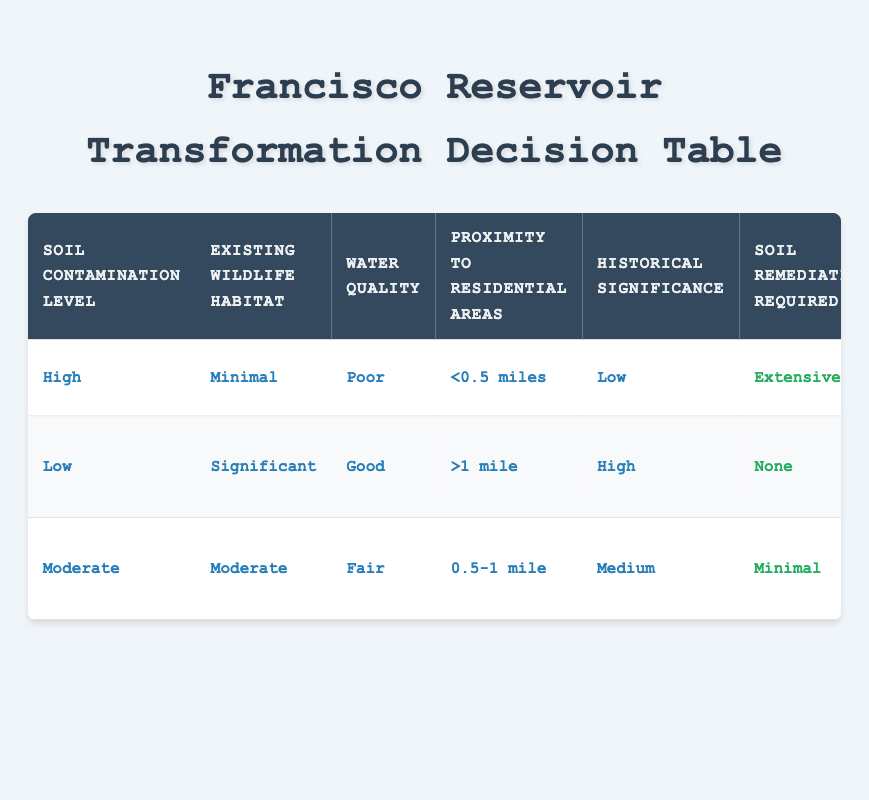What is the soil contamination level for the scenario with extensive soil remediation required? In the table, the row with the extensive soil remediation required corresponds to the conditions of "High" soil contamination level.
Answer: High Is habitat preservation required when there is significant existing wildlife habitat? The second row indicates that with significant wildlife habitat and low soil contamination, the action for habitat preservation is "Full preservation."
Answer: Yes What water treatment method is suggested when water quality is fair and there is moderate existing wildlife habitat? The third row shows that when water quality is fair with moderate habitat, the suggested water treatment method is "Bioremediation."
Answer: Bioremediation How many measures address historical preservation when historical significance is rated as high? In the table, with historical significance rated high, the historical preservation approach is "Preserve original structures," implying there is one measure addressing preservation.
Answer: 1 If soil contamination is low and the proximity to residential areas is over one mile, what measures are required? According to the second row, with low soil contamination and proximity greater than one mile, the required actions are "None" for soil remediation, "Full preservation" for habitat, "Filtration" for water treatment, "Not required" for noise mitigation, and "Preserve original structures" for historical preservation. Therefore, all measures are either none or preservation-oriented.
Answer: None, Full preservation, Filtration, Not required, Preserve original structures What is the average level of soil contamination across all scenarios in the table? Assigning numerical values to contamination levels: Low=1, Moderate=2, High=3. The values are High (3), Low (1), Moderate (2). The average is (3 + 1 + 2) / 3 = 2.
Answer: 2 Are extensive soil remediation measures required if the existing wildlife habitat is significant? In the table, there are no scenarios with significant wildlife habitat combined with extensive remediation measures. Therefore, extensive remediation is not required in that context.
Answer: No What is the most common noise mitigation measure across the scenarios presented? The first scenario requires "Sound barriers," the second scenario requires "Not required," and the third scenario requires "Limited construction hours." The most common is not applicable since no measure is repeated across the conditions.
Answer: No common measure 